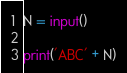<code> <loc_0><loc_0><loc_500><loc_500><_Python_>N = input()

print('ABC' + N)</code> 